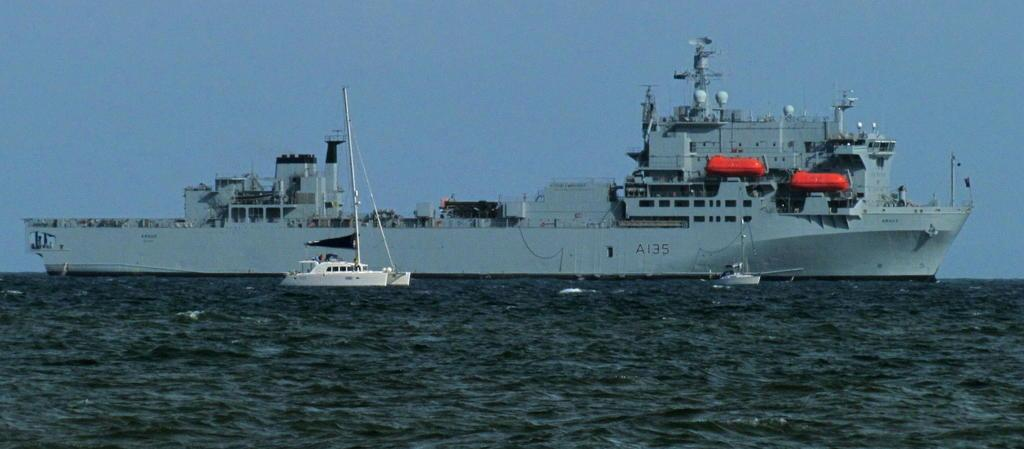<image>
Present a compact description of the photo's key features. A gray battleship with A135 along side in the ocean with a little white boat next to it. 